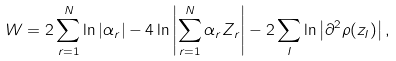Convert formula to latex. <formula><loc_0><loc_0><loc_500><loc_500>W = 2 \sum _ { r = 1 } ^ { N } \ln \left | \alpha _ { r } \right | - 4 \ln \left | \sum _ { r = 1 } ^ { N } \alpha _ { r } Z _ { r } \right | - 2 \sum _ { I } \ln \left | \partial ^ { 2 } \rho ( z _ { I } ) \right | ,</formula> 